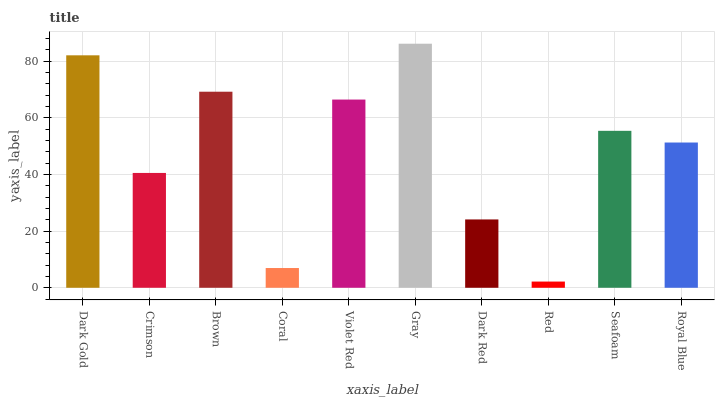Is Red the minimum?
Answer yes or no. Yes. Is Gray the maximum?
Answer yes or no. Yes. Is Crimson the minimum?
Answer yes or no. No. Is Crimson the maximum?
Answer yes or no. No. Is Dark Gold greater than Crimson?
Answer yes or no. Yes. Is Crimson less than Dark Gold?
Answer yes or no. Yes. Is Crimson greater than Dark Gold?
Answer yes or no. No. Is Dark Gold less than Crimson?
Answer yes or no. No. Is Seafoam the high median?
Answer yes or no. Yes. Is Royal Blue the low median?
Answer yes or no. Yes. Is Dark Gold the high median?
Answer yes or no. No. Is Violet Red the low median?
Answer yes or no. No. 